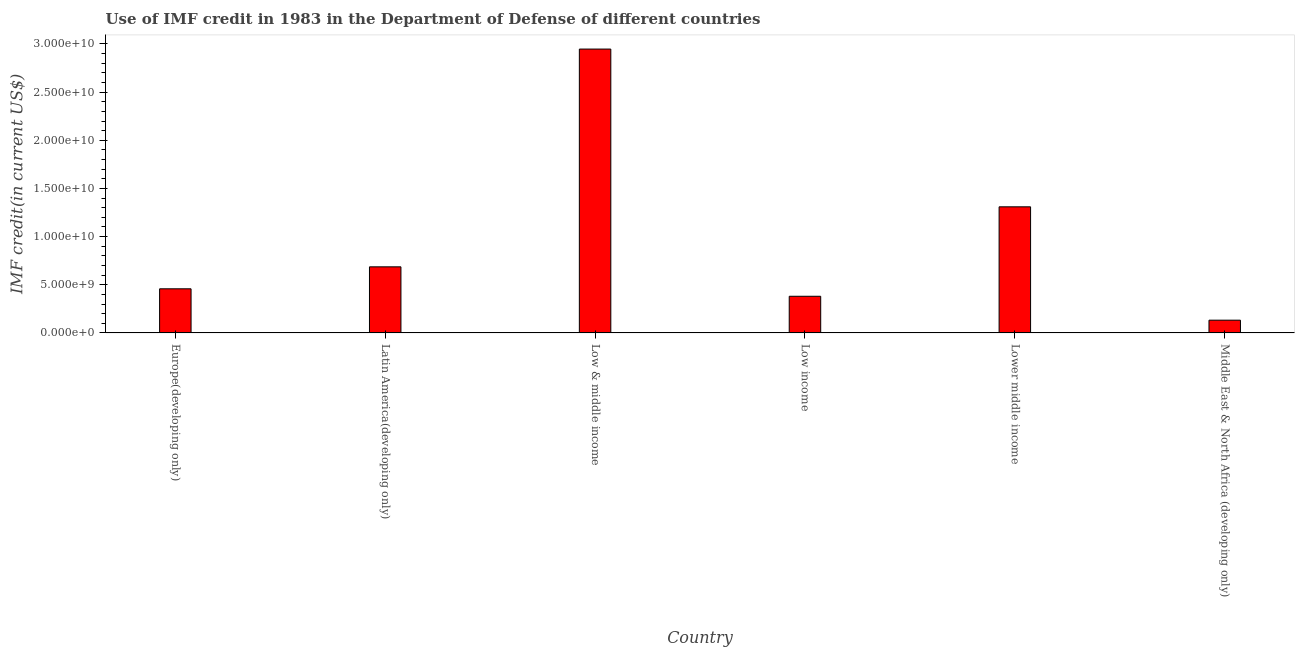Does the graph contain any zero values?
Keep it short and to the point. No. What is the title of the graph?
Your answer should be compact. Use of IMF credit in 1983 in the Department of Defense of different countries. What is the label or title of the Y-axis?
Your answer should be very brief. IMF credit(in current US$). What is the use of imf credit in dod in Low & middle income?
Your response must be concise. 2.95e+1. Across all countries, what is the maximum use of imf credit in dod?
Make the answer very short. 2.95e+1. Across all countries, what is the minimum use of imf credit in dod?
Your answer should be compact. 1.32e+09. In which country was the use of imf credit in dod minimum?
Your answer should be very brief. Middle East & North Africa (developing only). What is the sum of the use of imf credit in dod?
Make the answer very short. 5.91e+1. What is the difference between the use of imf credit in dod in Europe(developing only) and Low income?
Your answer should be very brief. 7.76e+08. What is the average use of imf credit in dod per country?
Offer a very short reply. 9.86e+09. What is the median use of imf credit in dod?
Your answer should be compact. 5.72e+09. What is the ratio of the use of imf credit in dod in Europe(developing only) to that in Low income?
Your answer should be compact. 1.2. Is the use of imf credit in dod in Europe(developing only) less than that in Latin America(developing only)?
Offer a terse response. Yes. Is the difference between the use of imf credit in dod in Low & middle income and Lower middle income greater than the difference between any two countries?
Ensure brevity in your answer.  No. What is the difference between the highest and the second highest use of imf credit in dod?
Make the answer very short. 1.64e+1. Is the sum of the use of imf credit in dod in Low & middle income and Lower middle income greater than the maximum use of imf credit in dod across all countries?
Your response must be concise. Yes. What is the difference between the highest and the lowest use of imf credit in dod?
Keep it short and to the point. 2.81e+1. In how many countries, is the use of imf credit in dod greater than the average use of imf credit in dod taken over all countries?
Your response must be concise. 2. What is the IMF credit(in current US$) of Europe(developing only)?
Offer a very short reply. 4.58e+09. What is the IMF credit(in current US$) of Latin America(developing only)?
Offer a very short reply. 6.86e+09. What is the IMF credit(in current US$) in Low & middle income?
Your response must be concise. 2.95e+1. What is the IMF credit(in current US$) of Low income?
Your response must be concise. 3.81e+09. What is the IMF credit(in current US$) in Lower middle income?
Your answer should be compact. 1.31e+1. What is the IMF credit(in current US$) in Middle East & North Africa (developing only)?
Your answer should be compact. 1.32e+09. What is the difference between the IMF credit(in current US$) in Europe(developing only) and Latin America(developing only)?
Offer a terse response. -2.28e+09. What is the difference between the IMF credit(in current US$) in Europe(developing only) and Low & middle income?
Your response must be concise. -2.49e+1. What is the difference between the IMF credit(in current US$) in Europe(developing only) and Low income?
Provide a succinct answer. 7.76e+08. What is the difference between the IMF credit(in current US$) in Europe(developing only) and Lower middle income?
Your response must be concise. -8.51e+09. What is the difference between the IMF credit(in current US$) in Europe(developing only) and Middle East & North Africa (developing only)?
Offer a terse response. 3.26e+09. What is the difference between the IMF credit(in current US$) in Latin America(developing only) and Low & middle income?
Provide a short and direct response. -2.26e+1. What is the difference between the IMF credit(in current US$) in Latin America(developing only) and Low income?
Provide a succinct answer. 3.06e+09. What is the difference between the IMF credit(in current US$) in Latin America(developing only) and Lower middle income?
Your answer should be very brief. -6.23e+09. What is the difference between the IMF credit(in current US$) in Latin America(developing only) and Middle East & North Africa (developing only)?
Keep it short and to the point. 5.54e+09. What is the difference between the IMF credit(in current US$) in Low & middle income and Low income?
Offer a terse response. 2.57e+1. What is the difference between the IMF credit(in current US$) in Low & middle income and Lower middle income?
Your response must be concise. 1.64e+1. What is the difference between the IMF credit(in current US$) in Low & middle income and Middle East & North Africa (developing only)?
Provide a succinct answer. 2.81e+1. What is the difference between the IMF credit(in current US$) in Low income and Lower middle income?
Keep it short and to the point. -9.29e+09. What is the difference between the IMF credit(in current US$) in Low income and Middle East & North Africa (developing only)?
Offer a terse response. 2.48e+09. What is the difference between the IMF credit(in current US$) in Lower middle income and Middle East & North Africa (developing only)?
Offer a terse response. 1.18e+1. What is the ratio of the IMF credit(in current US$) in Europe(developing only) to that in Latin America(developing only)?
Keep it short and to the point. 0.67. What is the ratio of the IMF credit(in current US$) in Europe(developing only) to that in Low & middle income?
Give a very brief answer. 0.15. What is the ratio of the IMF credit(in current US$) in Europe(developing only) to that in Low income?
Your response must be concise. 1.2. What is the ratio of the IMF credit(in current US$) in Europe(developing only) to that in Lower middle income?
Ensure brevity in your answer.  0.35. What is the ratio of the IMF credit(in current US$) in Europe(developing only) to that in Middle East & North Africa (developing only)?
Provide a short and direct response. 3.46. What is the ratio of the IMF credit(in current US$) in Latin America(developing only) to that in Low & middle income?
Give a very brief answer. 0.23. What is the ratio of the IMF credit(in current US$) in Latin America(developing only) to that in Low income?
Your answer should be very brief. 1.8. What is the ratio of the IMF credit(in current US$) in Latin America(developing only) to that in Lower middle income?
Keep it short and to the point. 0.52. What is the ratio of the IMF credit(in current US$) in Latin America(developing only) to that in Middle East & North Africa (developing only)?
Ensure brevity in your answer.  5.18. What is the ratio of the IMF credit(in current US$) in Low & middle income to that in Low income?
Provide a short and direct response. 7.74. What is the ratio of the IMF credit(in current US$) in Low & middle income to that in Lower middle income?
Your response must be concise. 2.25. What is the ratio of the IMF credit(in current US$) in Low & middle income to that in Middle East & North Africa (developing only)?
Provide a short and direct response. 22.25. What is the ratio of the IMF credit(in current US$) in Low income to that in Lower middle income?
Offer a terse response. 0.29. What is the ratio of the IMF credit(in current US$) in Low income to that in Middle East & North Africa (developing only)?
Your response must be concise. 2.87. What is the ratio of the IMF credit(in current US$) in Lower middle income to that in Middle East & North Africa (developing only)?
Provide a succinct answer. 9.88. 